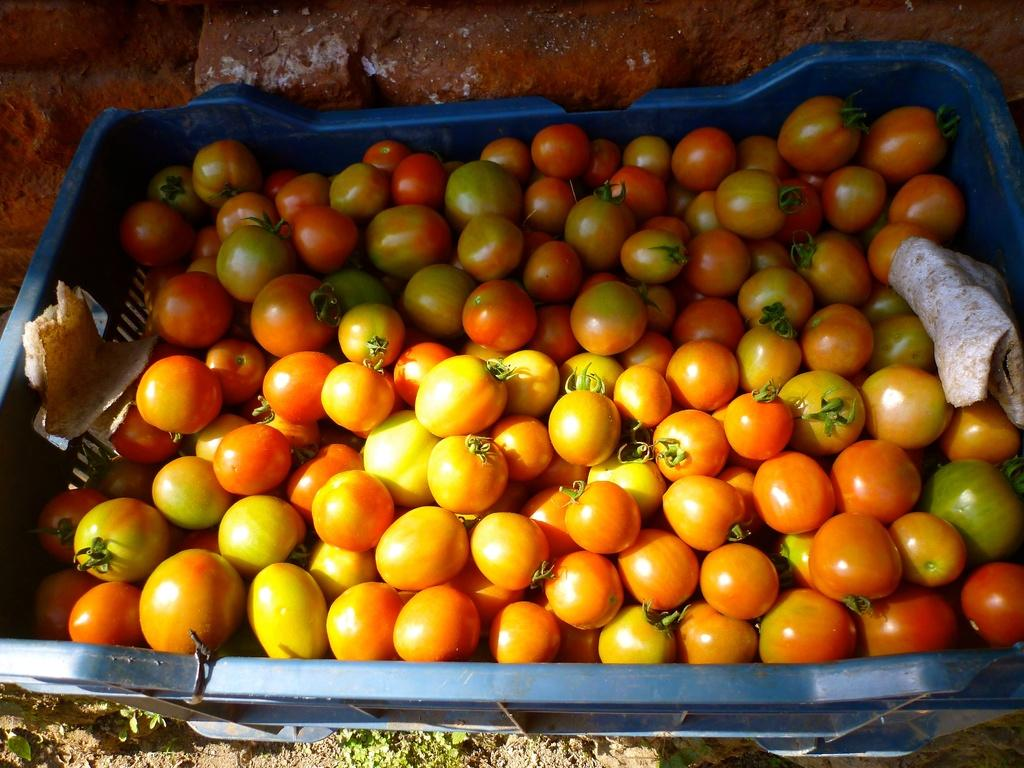What is the color of the basket in the image? The basket is blue. What is inside the basket? The basket contains tomatoes. What can be seen at the top of the image? There are bricks visible at the top of the image. What is visible at the bottom of the image? The ground is visible at the bottom of the image. What time of day is it in the image, based on the presence of cats? There are no cats present in the image, so we cannot determine the time of day based on their presence. 